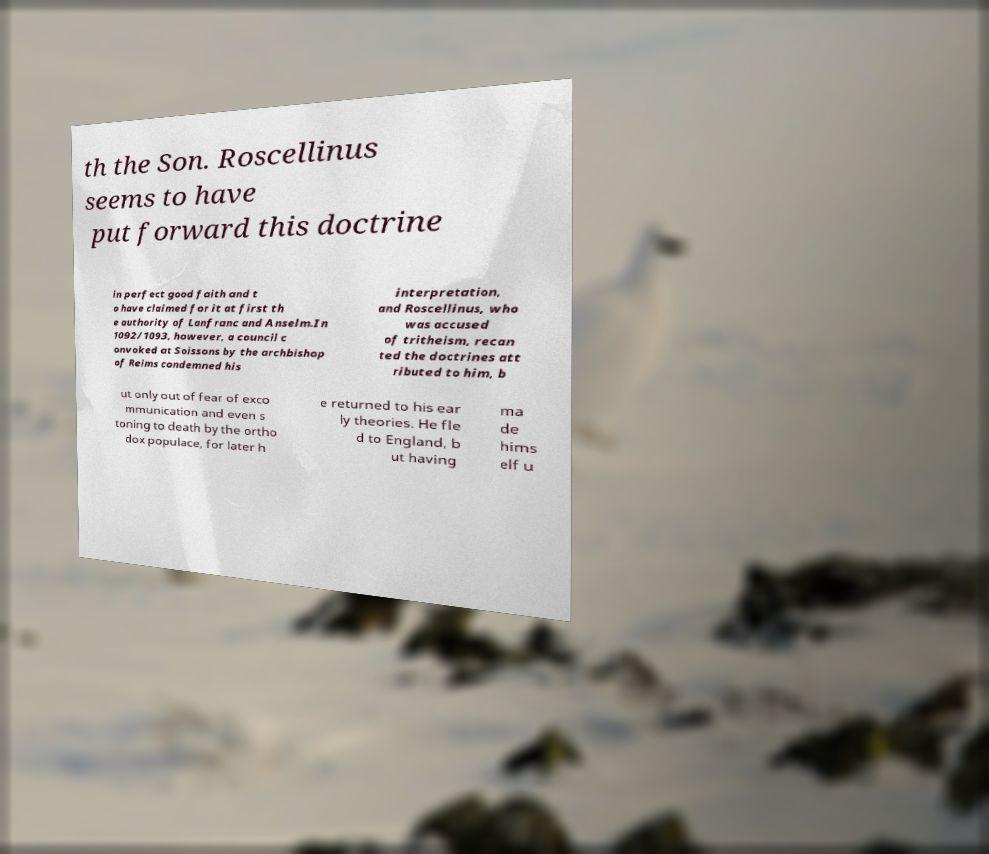Could you extract and type out the text from this image? th the Son. Roscellinus seems to have put forward this doctrine in perfect good faith and t o have claimed for it at first th e authority of Lanfranc and Anselm.In 1092/1093, however, a council c onvoked at Soissons by the archbishop of Reims condemned his interpretation, and Roscellinus, who was accused of tritheism, recan ted the doctrines att ributed to him, b ut only out of fear of exco mmunication and even s toning to death by the ortho dox populace, for later h e returned to his ear ly theories. He fle d to England, b ut having ma de hims elf u 